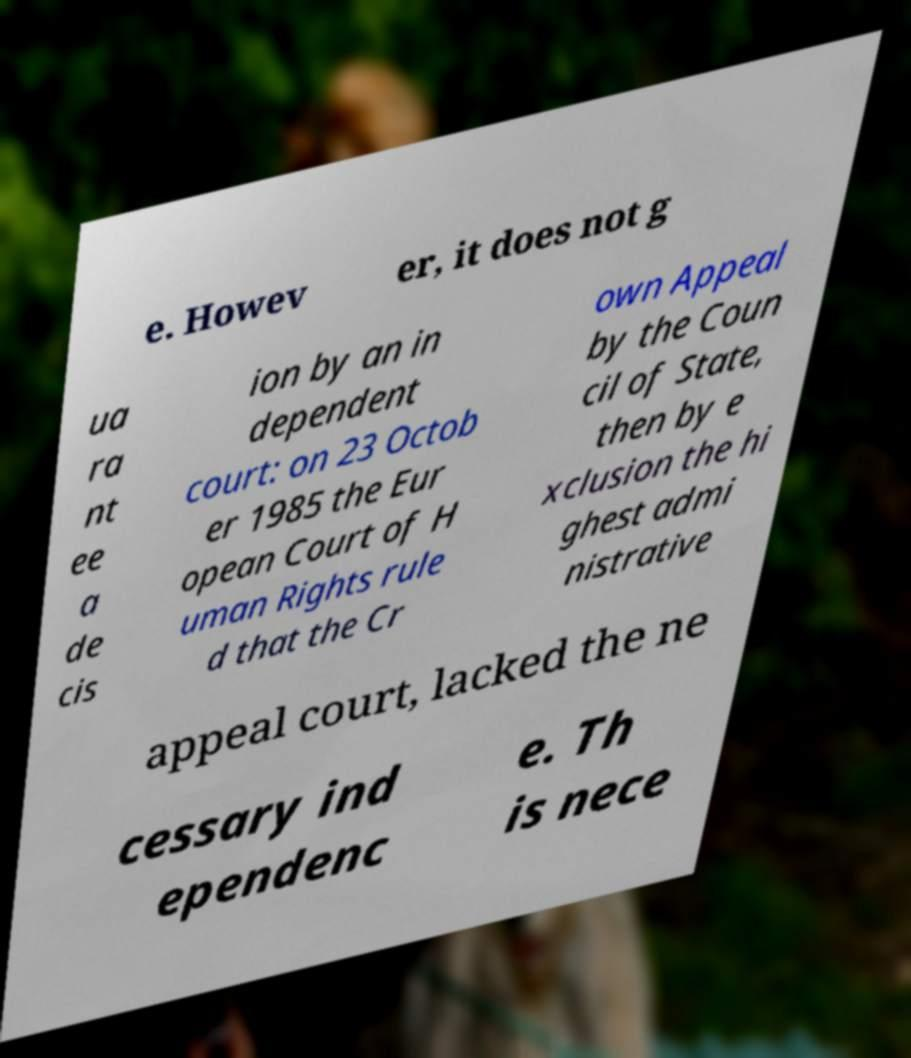There's text embedded in this image that I need extracted. Can you transcribe it verbatim? e. Howev er, it does not g ua ra nt ee a de cis ion by an in dependent court: on 23 Octob er 1985 the Eur opean Court of H uman Rights rule d that the Cr own Appeal by the Coun cil of State, then by e xclusion the hi ghest admi nistrative appeal court, lacked the ne cessary ind ependenc e. Th is nece 